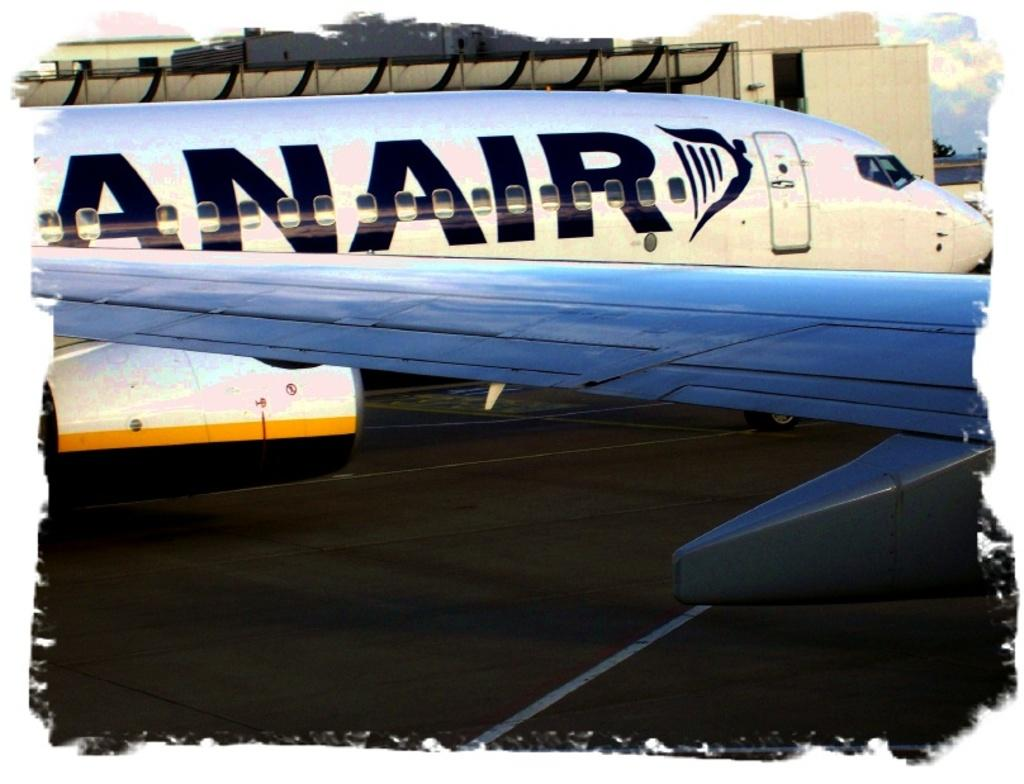What is located at the bottom of the image? There is a ground at the bottom of the image. What is the main subject in the middle of the image? There is an airplane in the middle of the image. What can be seen in the background of the image? There is a building in the background of the image. What is the mind of the airplane doing in the image? The concept of an airplane having a mind is not applicable, as airplanes are inanimate objects. How does the view of the building compare to the view of the airplane in the image? The question cannot be answered definitively, as the provided facts do not offer any information about the relative size or prominence of the airplane and the building in the image. 